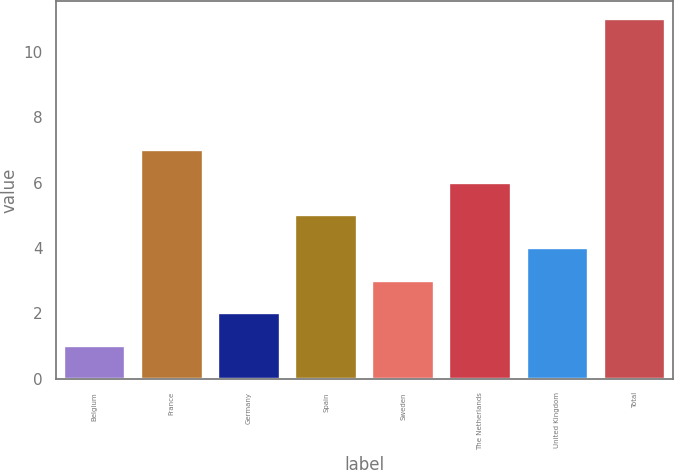Convert chart to OTSL. <chart><loc_0><loc_0><loc_500><loc_500><bar_chart><fcel>Belgium<fcel>France<fcel>Germany<fcel>Spain<fcel>Sweden<fcel>The Netherlands<fcel>United Kingdom<fcel>Total<nl><fcel>1<fcel>7<fcel>2<fcel>5<fcel>3<fcel>6<fcel>4<fcel>11<nl></chart> 